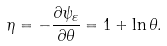<formula> <loc_0><loc_0><loc_500><loc_500>\eta = - \frac { \partial \psi _ { \varepsilon } } { \partial \theta } = 1 + \ln \theta .</formula> 